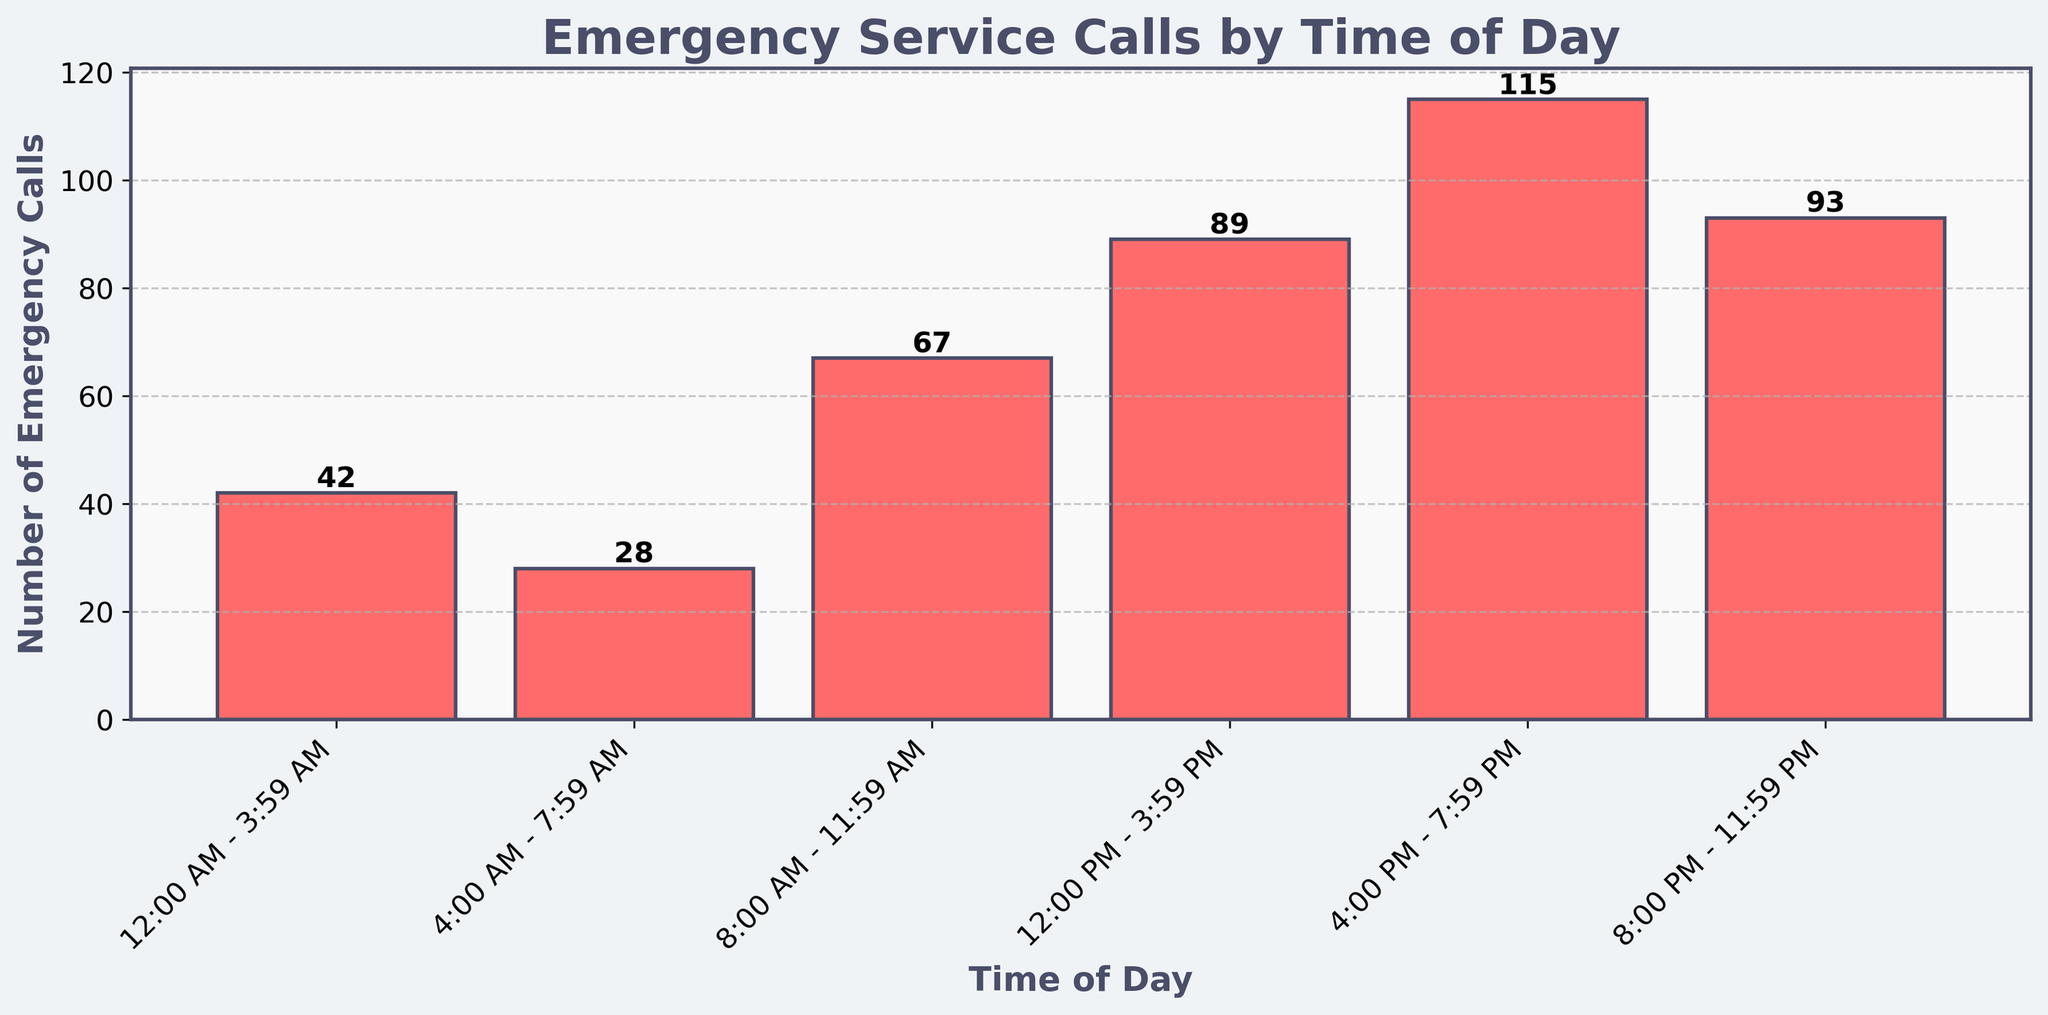What time of day had the highest number of emergency calls? To find the answer, observe the heights of all the bars in the chart and identify the tallest one. The 4:00 PM - 7:59 PM time slot has the highest bar, indicating the most calls.
Answer: 4:00 PM - 7:59 PM What is the total number of emergency calls from 12:00 PM to 11:59 PM? Sum the values of emergency calls for the time slots 12:00 PM - 3:59 PM, 4:00 PM - 7:59 PM, and 8:00 PM - 11:59 PM. 89 + 115 + 93 = 297.
Answer: 297 How many more emergency calls were made between 4:00 PM - 7:59 PM compared to 4:00 AM - 7:59 AM? Subtract the number of calls in the 4:00 AM - 7:59 AM slot from the number of calls in the 4:00 PM - 7:59 PM slot. 115 - 28 = 87.
Answer: 87 What is the average number of calls per time slot? Sum the total number of calls for all time slots and divide by the number of time slots. (42 + 28 + 67 + 89 + 115 + 93)/6 = 434/6 ≈ 72.33.
Answer: 72.33 Which time slot has the second-highest number of emergency calls? Identify the time slot with the highest number of calls (4:00 PM - 7:59 PM) and then look for the next highest bar. The second highest is the 8:00 PM - 11:59 PM time slot.
Answer: 8:00 PM - 11:59 PM What percentage of the total emergency calls were made between 8:00 AM - 11:59 AM? First, calculate the total number of calls by summing all the calls. Then, find the percentage by dividing the number of calls in the 8:00 AM - 11:59 AM slot by the total number and multiplying by 100. Total calls = 434. (67/434) * 100 ≈ 15.43%.
Answer: 15.43% Is there a significant increase in emergency calls between any two consecutive time slots? Compare the number of emergency calls between consecutive time slots to find a significant increase. The jump from 8:00 AM - 11:59 AM (67 calls) to 12:00 PM - 3:59 PM (89 calls), and from 12:00 PM - 3:59 PM (89 calls) to 4:00 PM - 7:59 PM (115 calls) are noticeable.
Answer: Yes Which time slot has the lowest number of emergency calls? Identify the shortest bar in the chart, which represents the time slot with the fewest calls. This is the 4:00 AM - 7:59 AM time slot.
Answer: 4:00 AM - 7:59 AM What is the difference in the number of emergency calls between the slots 12:00 AM - 3:59 AM and 12:00 PM - 3:59 PM? Subtract the number of calls in the 12:00 AM - 3:59 AM slot from the 12:00 PM - 3:59 PM slot. 89 - 42 = 47.
Answer: 47 Are there any time slots with fewer than 50 emergency calls? If so, which ones? Identify bars on the chart with heights corresponding to fewer than 50 calls. The time slots 12:00 AM - 3:59 AM and 4:00 AM - 7:59 AM both meet this criterion.
Answer: 12:00 AM - 3:59 AM, 4:00 AM - 7:59 AM 